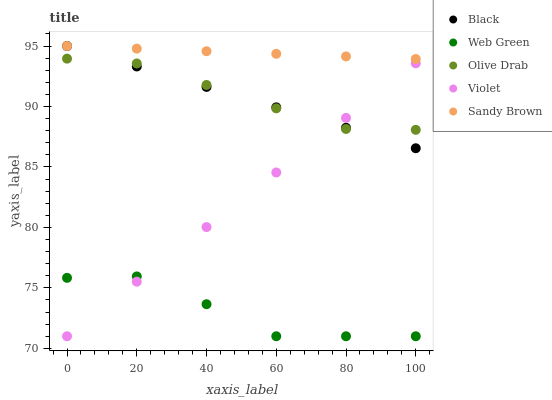Does Web Green have the minimum area under the curve?
Answer yes or no. Yes. Does Sandy Brown have the maximum area under the curve?
Answer yes or no. Yes. Does Black have the minimum area under the curve?
Answer yes or no. No. Does Black have the maximum area under the curve?
Answer yes or no. No. Is Black the smoothest?
Answer yes or no. Yes. Is Web Green the roughest?
Answer yes or no. Yes. Is Olive Drab the smoothest?
Answer yes or no. No. Is Olive Drab the roughest?
Answer yes or no. No. Does Web Green have the lowest value?
Answer yes or no. Yes. Does Black have the lowest value?
Answer yes or no. No. Does Black have the highest value?
Answer yes or no. Yes. Does Olive Drab have the highest value?
Answer yes or no. No. Is Web Green less than Black?
Answer yes or no. Yes. Is Sandy Brown greater than Olive Drab?
Answer yes or no. Yes. Does Violet intersect Black?
Answer yes or no. Yes. Is Violet less than Black?
Answer yes or no. No. Is Violet greater than Black?
Answer yes or no. No. Does Web Green intersect Black?
Answer yes or no. No. 